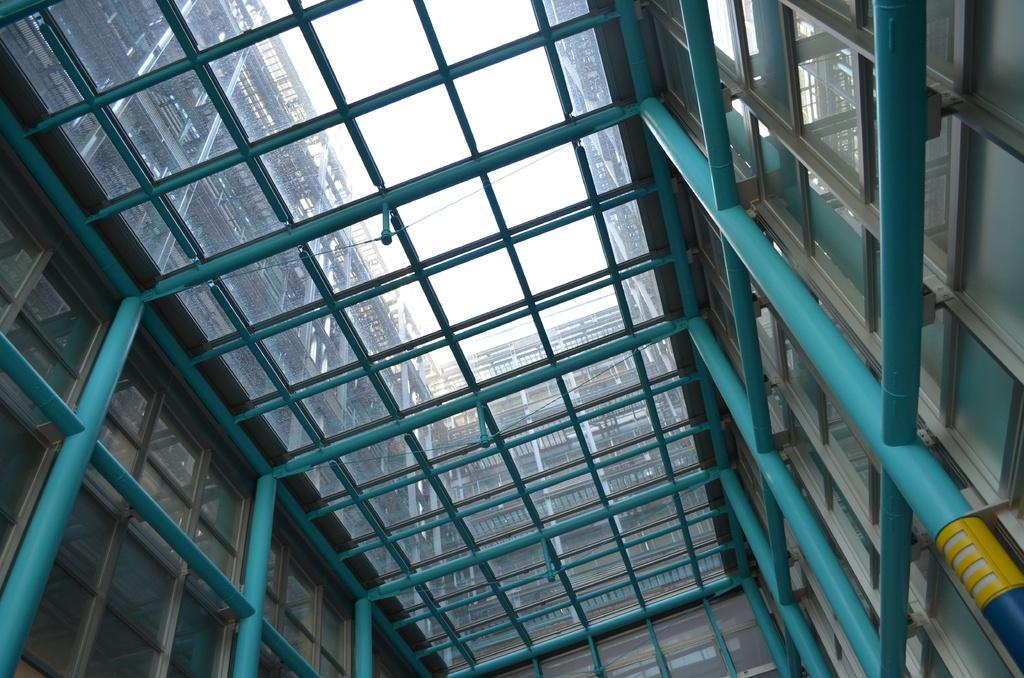What type of building is in the image? There is a big glass building in the image. What feature can be seen on the building? The building has blue poles. What is visible at the top of the building? The sky is visible at the top of the building. How many sisters are standing on the slope near the building in the image? There are no sisters or slope present in the image. 